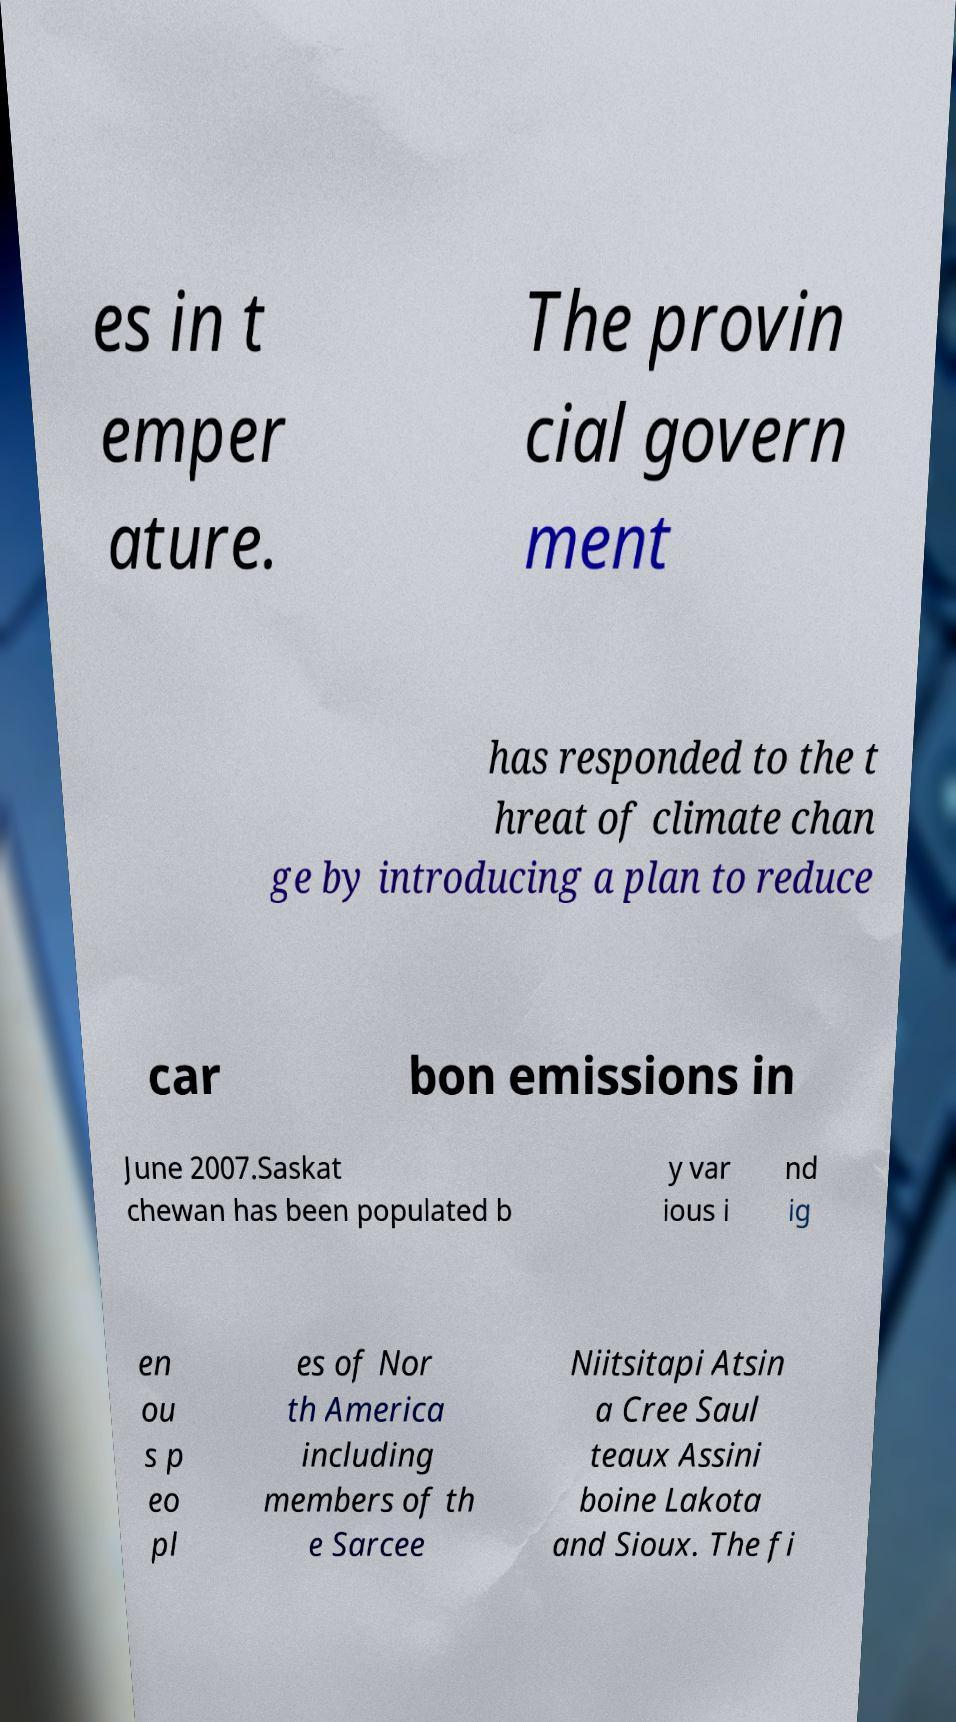Please identify and transcribe the text found in this image. es in t emper ature. The provin cial govern ment has responded to the t hreat of climate chan ge by introducing a plan to reduce car bon emissions in June 2007.Saskat chewan has been populated b y var ious i nd ig en ou s p eo pl es of Nor th America including members of th e Sarcee Niitsitapi Atsin a Cree Saul teaux Assini boine Lakota and Sioux. The fi 